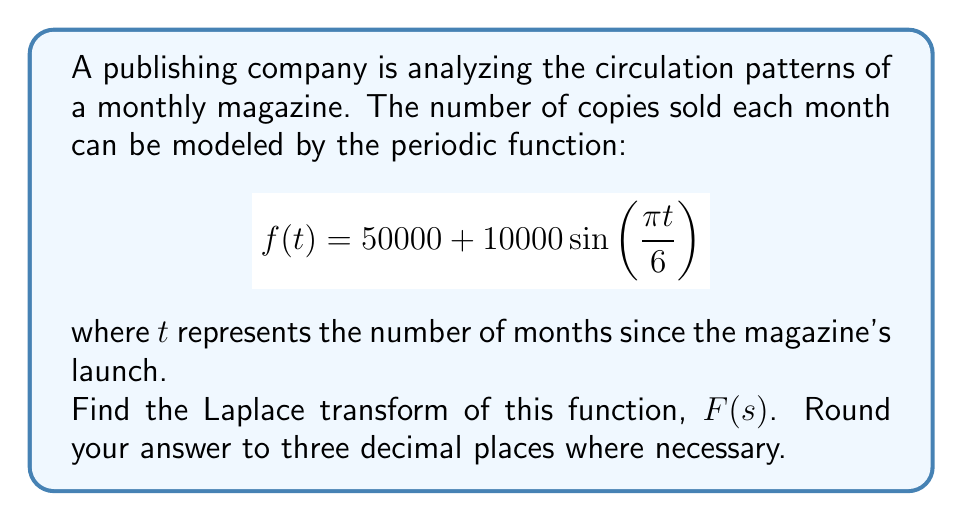Could you help me with this problem? Let's approach this step-by-step:

1) The Laplace transform of a function $f(t)$ is defined as:

   $$F(s) = \int_0^\infty e^{-st}f(t)dt$$

2) For our function $f(t) = 50000 + 10000\sin\left(\frac{\pi t}{6}\right)$, we need to find:

   $$F(s) = \int_0^\infty e^{-st}\left(50000 + 10000\sin\left(\frac{\pi t}{6}\right)\right)dt$$

3) We can split this into two integrals:

   $$F(s) = 50000\int_0^\infty e^{-st}dt + 10000\int_0^\infty e^{-st}\sin\left(\frac{\pi t}{6}\right)dt$$

4) For the first integral:

   $$50000\int_0^\infty e^{-st}dt = 50000 \cdot \frac{1}{s}$$

5) For the second integral, we can use the Laplace transform of sine:

   $$\mathcal{L}\{\sin(at)\} = \frac{a}{s^2 + a^2}$$

   Here, $a = \frac{\pi}{6}$

6) Therefore, the second integral becomes:

   $$10000\int_0^\infty e^{-st}\sin\left(\frac{\pi t}{6}\right)dt = 10000 \cdot \frac{\frac{\pi}{6}}{s^2 + (\frac{\pi}{6})^2}$$

7) Combining the results from steps 4 and 6:

   $$F(s) = \frac{50000}{s} + \frac{10000\pi}{6s^2 + \pi^2}$$

8) Simplifying:

   $$F(s) = \frac{50000}{s} + \frac{5000\pi}{3s^2 + \frac{\pi^2}{2}}$$

9) Rounding to three decimal places:

   $$F(s) = \frac{50000}{s} + \frac{15707.963}{s^2 + 1.645}$$
Answer: $$F(s) = \frac{50000}{s} + \frac{15707.963}{s^2 + 1.645}$$ 